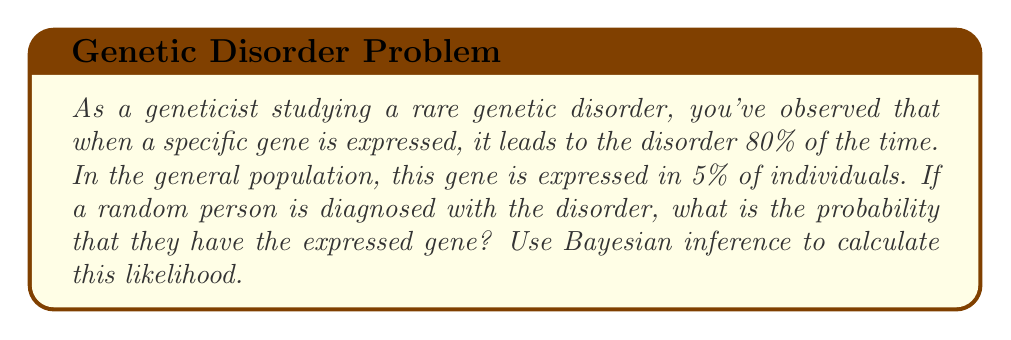Can you solve this math problem? Let's approach this problem using Bayesian inference:

1. Define our events:
   A: The person has the expressed gene
   B: The person has the disorder

2. Given information:
   P(B|A) = 0.80 (probability of disorder given the gene is expressed)
   P(A) = 0.05 (probability of gene expression in general population)
   We need to find P(A|B) (probability of gene expression given the disorder)

3. Bayes' theorem states:

   $$P(A|B) = \frac{P(B|A) \cdot P(A)}{P(B)}$$

4. We know P(B|A) and P(A), but we need to calculate P(B):

   $$P(B) = P(B|A) \cdot P(A) + P(B|\text{not}A) \cdot P(\text{not}A)$$

5. We don't know P(B|notA) directly, but we can assume that if the gene is not expressed, the probability of the disorder is very low. Let's assume it's 1%. So:

   P(B|notA) = 0.01
   P(notA) = 1 - P(A) = 0.95

6. Now we can calculate P(B):

   $$P(B) = 0.80 \cdot 0.05 + 0.01 \cdot 0.95 = 0.04 + 0.0095 = 0.0495$$

7. Finally, we can apply Bayes' theorem:

   $$P(A|B) = \frac{0.80 \cdot 0.05}{0.0495} = \frac{0.04}{0.0495} \approx 0.8081$$

Thus, the probability that a person diagnosed with the disorder has the expressed gene is approximately 0.8081 or 80.81%.
Answer: $0.8081$ or $80.81\%$ 